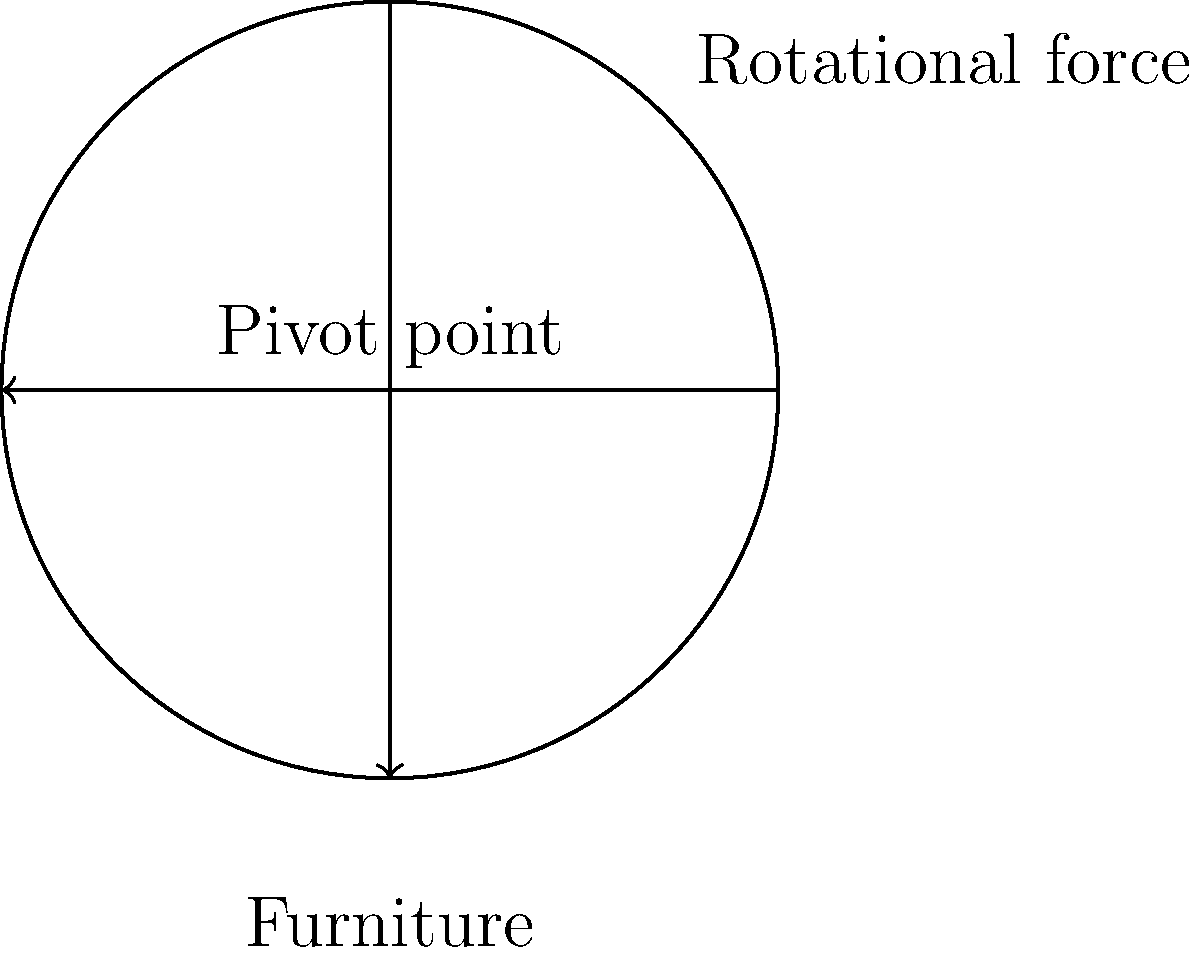When pivoting a large piece of furniture around a central point, what is the relationship between the applied force (F), the distance from the pivot point to the point of force application (r), and the torque (τ) produced? To understand the relationship between force, distance, and torque when pivoting a large piece of furniture, we need to follow these steps:

1. Recall the formula for torque:
   τ = F * r * sin(θ)

   Where:
   τ = torque
   F = applied force
   r = distance from pivot point to point of force application
   θ = angle between the force vector and the lever arm

2. In the case of pivoting furniture, we typically apply force perpendicular to the lever arm, so sin(θ) = 1.

3. This simplifies our equation to:
   τ = F * r

4. From this equation, we can deduce that:
   - Torque is directly proportional to both force and distance.
   - Increasing either the force or the distance from the pivot point will increase the torque.
   - Doubling either the force or the distance will double the torque.

5. In practical terms for a mover:
   - Applying force farther from the pivot point (e.g., at the edge of the furniture) requires less effort to produce the same torque.
   - When pivoting heavy furniture, it's more efficient to push or pull at the points farthest from the pivot.

6. The relationship is linear: doubling the force or doubling the distance will double the torque produced.
Answer: τ = F * r (Torque is directly proportional to force and distance from pivot) 